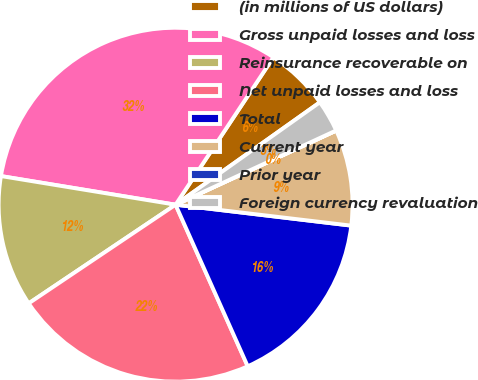<chart> <loc_0><loc_0><loc_500><loc_500><pie_chart><fcel>(in millions of US dollars)<fcel>Gross unpaid losses and loss<fcel>Reinsurance recoverable on<fcel>Net unpaid losses and loss<fcel>Total<fcel>Current year<fcel>Prior year<fcel>Foreign currency revaluation<nl><fcel>5.85%<fcel>31.74%<fcel>12.0%<fcel>22.27%<fcel>16.43%<fcel>8.77%<fcel>0.01%<fcel>2.93%<nl></chart> 